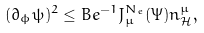Convert formula to latex. <formula><loc_0><loc_0><loc_500><loc_500>( \partial _ { \phi } \psi ) ^ { 2 } \leq B e ^ { - 1 } J _ { \mu } ^ { N _ { e } } ( \Psi ) n ^ { \mu } _ { \mathcal { H } } ,</formula> 